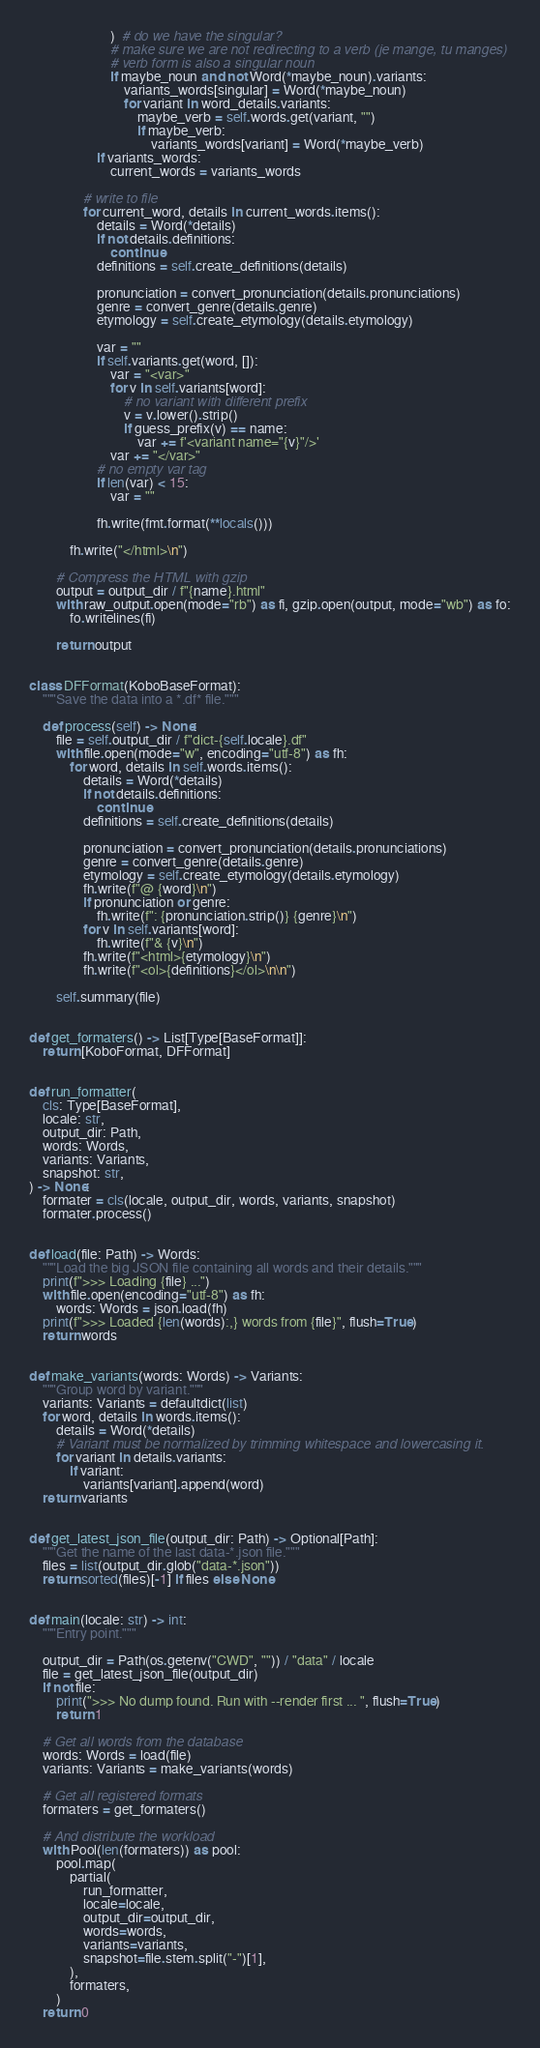Convert code to text. <code><loc_0><loc_0><loc_500><loc_500><_Python_>                        )  # do we have the singular?
                        # make sure we are not redirecting to a verb (je mange, tu manges)
                        # verb form is also a singular noun
                        if maybe_noun and not Word(*maybe_noun).variants:
                            variants_words[singular] = Word(*maybe_noun)
                            for variant in word_details.variants:
                                maybe_verb = self.words.get(variant, "")
                                if maybe_verb:
                                    variants_words[variant] = Word(*maybe_verb)
                    if variants_words:
                        current_words = variants_words

                # write to file
                for current_word, details in current_words.items():
                    details = Word(*details)
                    if not details.definitions:
                        continue
                    definitions = self.create_definitions(details)

                    pronunciation = convert_pronunciation(details.pronunciations)
                    genre = convert_genre(details.genre)
                    etymology = self.create_etymology(details.etymology)

                    var = ""
                    if self.variants.get(word, []):
                        var = "<var>"
                        for v in self.variants[word]:
                            # no variant with different prefix
                            v = v.lower().strip()
                            if guess_prefix(v) == name:
                                var += f'<variant name="{v}"/>'
                        var += "</var>"
                    # no empty var tag
                    if len(var) < 15:
                        var = ""

                    fh.write(fmt.format(**locals()))

            fh.write("</html>\n")

        # Compress the HTML with gzip
        output = output_dir / f"{name}.html"
        with raw_output.open(mode="rb") as fi, gzip.open(output, mode="wb") as fo:
            fo.writelines(fi)

        return output


class DFFormat(KoboBaseFormat):
    """Save the data into a *.df* file."""

    def process(self) -> None:
        file = self.output_dir / f"dict-{self.locale}.df"
        with file.open(mode="w", encoding="utf-8") as fh:
            for word, details in self.words.items():
                details = Word(*details)
                if not details.definitions:
                    continue
                definitions = self.create_definitions(details)

                pronunciation = convert_pronunciation(details.pronunciations)
                genre = convert_genre(details.genre)
                etymology = self.create_etymology(details.etymology)
                fh.write(f"@ {word}\n")
                if pronunciation or genre:
                    fh.write(f": {pronunciation.strip()} {genre}\n")
                for v in self.variants[word]:
                    fh.write(f"& {v}\n")
                fh.write(f"<html>{etymology}\n")
                fh.write(f"<ol>{definitions}</ol>\n\n")

        self.summary(file)


def get_formaters() -> List[Type[BaseFormat]]:
    return [KoboFormat, DFFormat]


def run_formatter(
    cls: Type[BaseFormat],
    locale: str,
    output_dir: Path,
    words: Words,
    variants: Variants,
    snapshot: str,
) -> None:
    formater = cls(locale, output_dir, words, variants, snapshot)
    formater.process()


def load(file: Path) -> Words:
    """Load the big JSON file containing all words and their details."""
    print(f">>> Loading {file} ...")
    with file.open(encoding="utf-8") as fh:
        words: Words = json.load(fh)
    print(f">>> Loaded {len(words):,} words from {file}", flush=True)
    return words


def make_variants(words: Words) -> Variants:
    """Group word by variant."""
    variants: Variants = defaultdict(list)
    for word, details in words.items():
        details = Word(*details)
        # Variant must be normalized by trimming whitespace and lowercasing it.
        for variant in details.variants:
            if variant:
                variants[variant].append(word)
    return variants


def get_latest_json_file(output_dir: Path) -> Optional[Path]:
    """Get the name of the last data-*.json file."""
    files = list(output_dir.glob("data-*.json"))
    return sorted(files)[-1] if files else None


def main(locale: str) -> int:
    """Entry point."""

    output_dir = Path(os.getenv("CWD", "")) / "data" / locale
    file = get_latest_json_file(output_dir)
    if not file:
        print(">>> No dump found. Run with --render first ... ", flush=True)
        return 1

    # Get all words from the database
    words: Words = load(file)
    variants: Variants = make_variants(words)

    # Get all registered formats
    formaters = get_formaters()

    # And distribute the workload
    with Pool(len(formaters)) as pool:
        pool.map(
            partial(
                run_formatter,
                locale=locale,
                output_dir=output_dir,
                words=words,
                variants=variants,
                snapshot=file.stem.split("-")[1],
            ),
            formaters,
        )
    return 0
</code> 